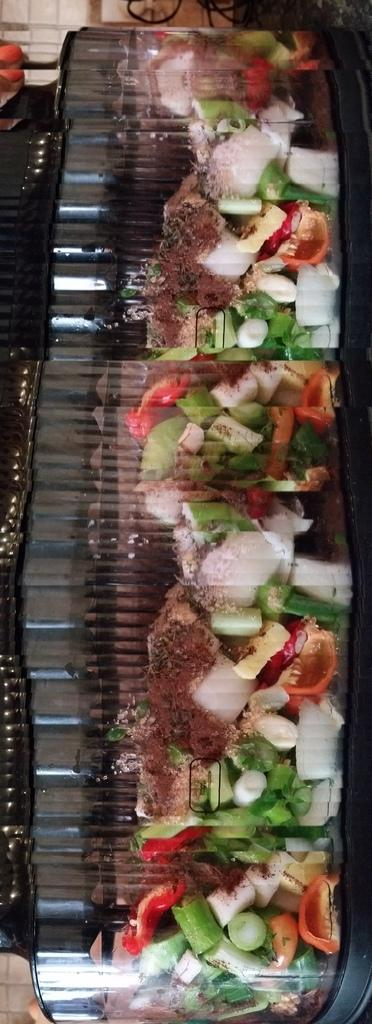What is present in the image related to food? There is food in the image. How are the food items arranged or stored in the image? The food is packed in plastic containers. What type of sail can be seen on the coast in the image? There is no sail or coast present in the image; it only features food packed in plastic containers. 